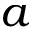Convert formula to latex. <formula><loc_0><loc_0><loc_500><loc_500>a</formula> 